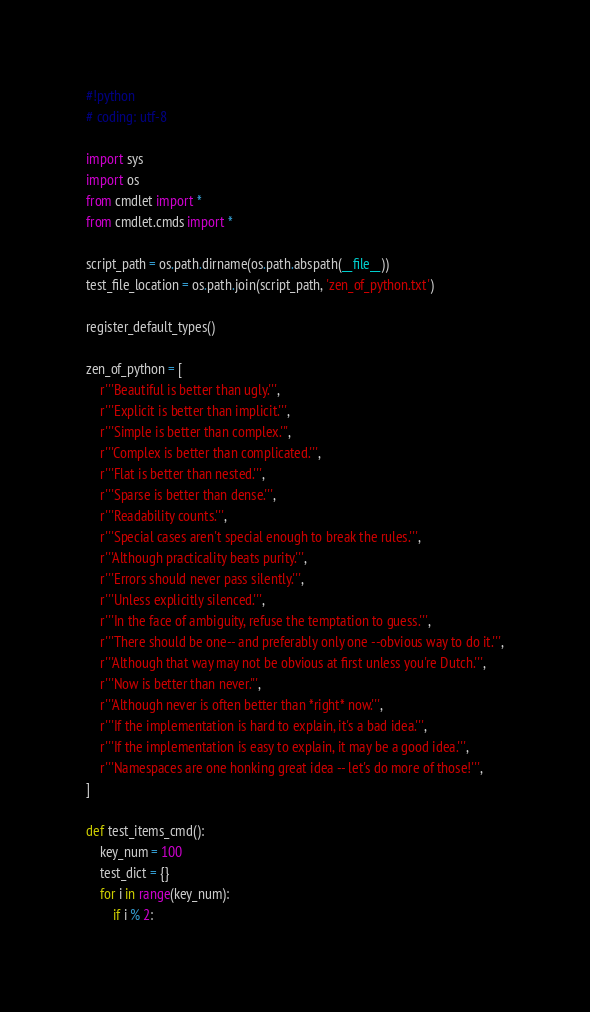Convert code to text. <code><loc_0><loc_0><loc_500><loc_500><_Python_>#!python
# coding: utf-8

import sys
import os
from cmdlet import *
from cmdlet.cmds import *

script_path = os.path.dirname(os.path.abspath(__file__))
test_file_location = os.path.join(script_path, 'zen_of_python.txt')

register_default_types()

zen_of_python = [
    r'''Beautiful is better than ugly.''',
    r'''Explicit is better than implicit.''',
    r'''Simple is better than complex.''',
    r'''Complex is better than complicated.''',
    r'''Flat is better than nested.''',
    r'''Sparse is better than dense.''',
    r'''Readability counts.''',
    r'''Special cases aren't special enough to break the rules.''',
    r'''Although practicality beats purity.''',
    r'''Errors should never pass silently.''',
    r'''Unless explicitly silenced.''',
    r'''In the face of ambiguity, refuse the temptation to guess.''',
    r'''There should be one-- and preferably only one --obvious way to do it.''',
    r'''Although that way may not be obvious at first unless you're Dutch.''',
    r'''Now is better than never.''',
    r'''Although never is often better than *right* now.''',
    r'''If the implementation is hard to explain, it's a bad idea.''',
    r'''If the implementation is easy to explain, it may be a good idea.''',
    r'''Namespaces are one honking great idea -- let's do more of those!''',
]

def test_items_cmd():
    key_num = 100
    test_dict = {}
    for i in range(key_num):
        if i % 2:</code> 